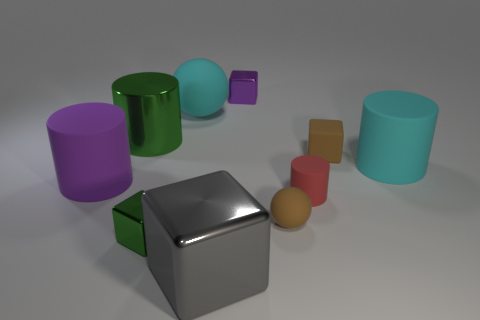There is a rubber sphere to the right of the big object in front of the small red thing that is on the right side of the green metal cylinder; what is its size?
Your answer should be compact. Small. How many other things are there of the same material as the large cyan cylinder?
Keep it short and to the point. 5. There is a cyan cylinder in front of the purple cube; what size is it?
Provide a short and direct response. Large. What number of things are behind the big matte ball and on the left side of the large green thing?
Offer a terse response. 0. What is the material of the ball that is behind the brown object behind the tiny brown ball?
Offer a terse response. Rubber. There is a large thing that is the same shape as the small green thing; what is its material?
Ensure brevity in your answer.  Metal. Are there any tiny brown blocks?
Ensure brevity in your answer.  Yes. The large thing that is the same material as the gray cube is what shape?
Keep it short and to the point. Cylinder. What material is the gray object in front of the large cyan matte ball?
Your answer should be compact. Metal. Do the tiny object that is behind the large rubber ball and the tiny matte ball have the same color?
Make the answer very short. No. 